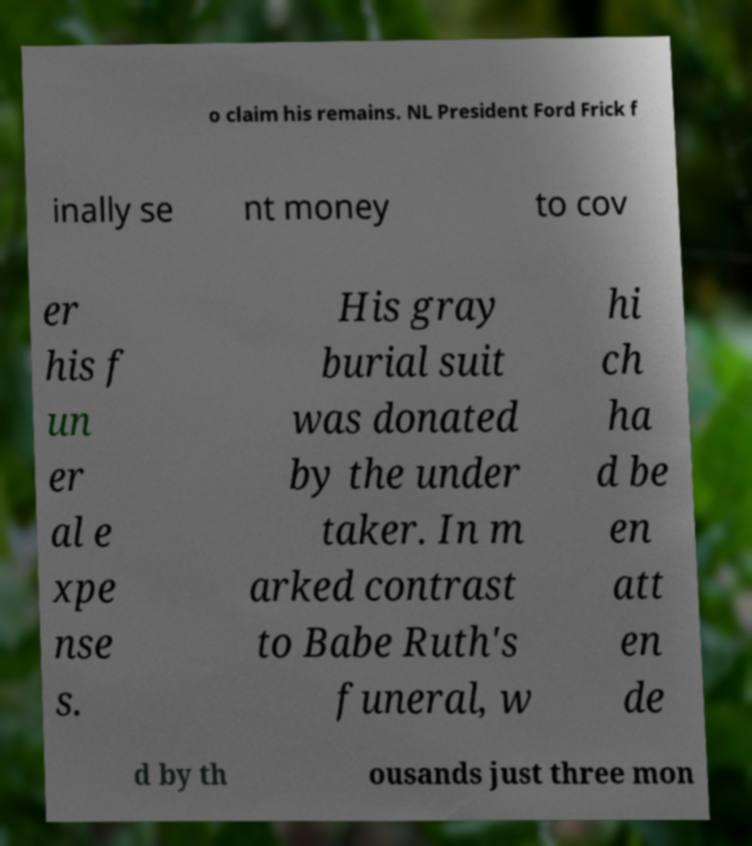Can you accurately transcribe the text from the provided image for me? o claim his remains. NL President Ford Frick f inally se nt money to cov er his f un er al e xpe nse s. His gray burial suit was donated by the under taker. In m arked contrast to Babe Ruth's funeral, w hi ch ha d be en att en de d by th ousands just three mon 